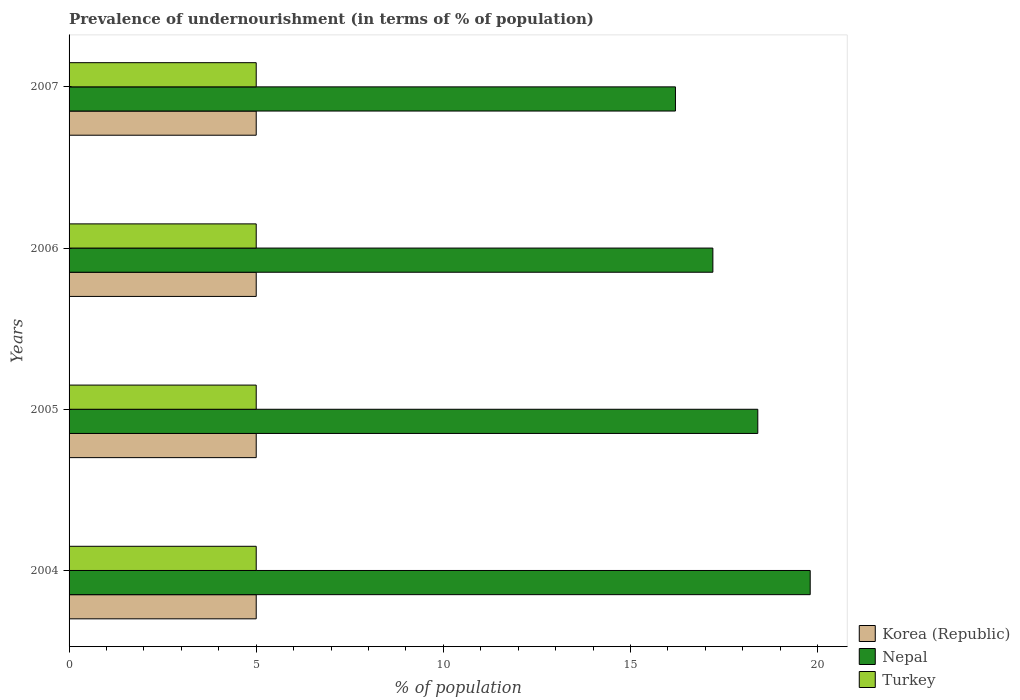How many different coloured bars are there?
Your answer should be very brief. 3. Are the number of bars per tick equal to the number of legend labels?
Provide a succinct answer. Yes. How many bars are there on the 1st tick from the top?
Ensure brevity in your answer.  3. What is the label of the 1st group of bars from the top?
Your response must be concise. 2007. What is the percentage of undernourished population in Nepal in 2004?
Give a very brief answer. 19.8. Across all years, what is the maximum percentage of undernourished population in Nepal?
Your answer should be very brief. 19.8. Across all years, what is the minimum percentage of undernourished population in Nepal?
Provide a succinct answer. 16.2. In which year was the percentage of undernourished population in Nepal maximum?
Provide a succinct answer. 2004. In which year was the percentage of undernourished population in Nepal minimum?
Make the answer very short. 2007. What is the total percentage of undernourished population in Korea (Republic) in the graph?
Provide a short and direct response. 20. What is the difference between the percentage of undernourished population in Nepal in 2004 and that in 2005?
Provide a succinct answer. 1.4. What is the average percentage of undernourished population in Turkey per year?
Give a very brief answer. 5. In how many years, is the percentage of undernourished population in Turkey greater than 3 %?
Offer a terse response. 4. Is the percentage of undernourished population in Korea (Republic) in 2004 less than that in 2006?
Your answer should be very brief. No. What is the difference between the highest and the second highest percentage of undernourished population in Korea (Republic)?
Offer a terse response. 0. What is the difference between the highest and the lowest percentage of undernourished population in Nepal?
Offer a very short reply. 3.6. What does the 2nd bar from the bottom in 2007 represents?
Your answer should be very brief. Nepal. How many bars are there?
Your answer should be very brief. 12. Are the values on the major ticks of X-axis written in scientific E-notation?
Give a very brief answer. No. Does the graph contain any zero values?
Provide a short and direct response. No. Does the graph contain grids?
Your response must be concise. No. Where does the legend appear in the graph?
Offer a very short reply. Bottom right. How many legend labels are there?
Give a very brief answer. 3. How are the legend labels stacked?
Make the answer very short. Vertical. What is the title of the graph?
Ensure brevity in your answer.  Prevalence of undernourishment (in terms of % of population). Does "Armenia" appear as one of the legend labels in the graph?
Your answer should be very brief. No. What is the label or title of the X-axis?
Give a very brief answer. % of population. What is the % of population of Korea (Republic) in 2004?
Offer a very short reply. 5. What is the % of population of Nepal in 2004?
Provide a short and direct response. 19.8. What is the % of population in Korea (Republic) in 2005?
Your answer should be very brief. 5. What is the % of population in Turkey in 2005?
Keep it short and to the point. 5. What is the % of population in Nepal in 2006?
Provide a short and direct response. 17.2. What is the % of population of Korea (Republic) in 2007?
Give a very brief answer. 5. Across all years, what is the maximum % of population in Korea (Republic)?
Provide a succinct answer. 5. Across all years, what is the maximum % of population of Nepal?
Give a very brief answer. 19.8. Across all years, what is the maximum % of population in Turkey?
Keep it short and to the point. 5. Across all years, what is the minimum % of population of Korea (Republic)?
Provide a succinct answer. 5. Across all years, what is the minimum % of population in Nepal?
Make the answer very short. 16.2. Across all years, what is the minimum % of population of Turkey?
Offer a terse response. 5. What is the total % of population in Korea (Republic) in the graph?
Your answer should be very brief. 20. What is the total % of population in Nepal in the graph?
Keep it short and to the point. 71.6. What is the total % of population in Turkey in the graph?
Offer a very short reply. 20. What is the difference between the % of population of Korea (Republic) in 2004 and that in 2005?
Offer a terse response. 0. What is the difference between the % of population in Turkey in 2004 and that in 2005?
Offer a very short reply. 0. What is the difference between the % of population of Nepal in 2004 and that in 2006?
Your answer should be compact. 2.6. What is the difference between the % of population of Korea (Republic) in 2004 and that in 2007?
Offer a terse response. 0. What is the difference between the % of population in Korea (Republic) in 2005 and that in 2006?
Make the answer very short. 0. What is the difference between the % of population of Turkey in 2005 and that in 2006?
Offer a terse response. 0. What is the difference between the % of population in Nepal in 2005 and that in 2007?
Give a very brief answer. 2.2. What is the difference between the % of population of Turkey in 2006 and that in 2007?
Keep it short and to the point. 0. What is the difference between the % of population in Korea (Republic) in 2004 and the % of population in Turkey in 2005?
Your response must be concise. 0. What is the difference between the % of population of Korea (Republic) in 2004 and the % of population of Nepal in 2006?
Your response must be concise. -12.2. What is the difference between the % of population in Korea (Republic) in 2004 and the % of population in Turkey in 2006?
Ensure brevity in your answer.  0. What is the difference between the % of population in Nepal in 2004 and the % of population in Turkey in 2006?
Make the answer very short. 14.8. What is the difference between the % of population of Korea (Republic) in 2004 and the % of population of Nepal in 2007?
Offer a terse response. -11.2. What is the difference between the % of population in Korea (Republic) in 2005 and the % of population in Nepal in 2006?
Offer a terse response. -12.2. What is the difference between the % of population of Nepal in 2005 and the % of population of Turkey in 2006?
Provide a succinct answer. 13.4. What is the difference between the % of population in Nepal in 2005 and the % of population in Turkey in 2007?
Offer a terse response. 13.4. What is the average % of population in Korea (Republic) per year?
Keep it short and to the point. 5. What is the average % of population in Nepal per year?
Give a very brief answer. 17.9. In the year 2004, what is the difference between the % of population of Korea (Republic) and % of population of Nepal?
Your response must be concise. -14.8. In the year 2004, what is the difference between the % of population in Korea (Republic) and % of population in Turkey?
Your answer should be compact. 0. In the year 2004, what is the difference between the % of population of Nepal and % of population of Turkey?
Your response must be concise. 14.8. In the year 2005, what is the difference between the % of population in Korea (Republic) and % of population in Nepal?
Your answer should be very brief. -13.4. In the year 2005, what is the difference between the % of population of Korea (Republic) and % of population of Turkey?
Give a very brief answer. 0. In the year 2006, what is the difference between the % of population in Korea (Republic) and % of population in Nepal?
Ensure brevity in your answer.  -12.2. In the year 2006, what is the difference between the % of population in Korea (Republic) and % of population in Turkey?
Keep it short and to the point. 0. In the year 2006, what is the difference between the % of population in Nepal and % of population in Turkey?
Make the answer very short. 12.2. In the year 2007, what is the difference between the % of population in Korea (Republic) and % of population in Nepal?
Provide a short and direct response. -11.2. In the year 2007, what is the difference between the % of population of Korea (Republic) and % of population of Turkey?
Provide a succinct answer. 0. In the year 2007, what is the difference between the % of population in Nepal and % of population in Turkey?
Offer a terse response. 11.2. What is the ratio of the % of population in Nepal in 2004 to that in 2005?
Make the answer very short. 1.08. What is the ratio of the % of population of Korea (Republic) in 2004 to that in 2006?
Your response must be concise. 1. What is the ratio of the % of population in Nepal in 2004 to that in 2006?
Your answer should be very brief. 1.15. What is the ratio of the % of population of Nepal in 2004 to that in 2007?
Make the answer very short. 1.22. What is the ratio of the % of population in Korea (Republic) in 2005 to that in 2006?
Make the answer very short. 1. What is the ratio of the % of population in Nepal in 2005 to that in 2006?
Provide a short and direct response. 1.07. What is the ratio of the % of population of Turkey in 2005 to that in 2006?
Offer a very short reply. 1. What is the ratio of the % of population of Korea (Republic) in 2005 to that in 2007?
Ensure brevity in your answer.  1. What is the ratio of the % of population of Nepal in 2005 to that in 2007?
Provide a succinct answer. 1.14. What is the ratio of the % of population in Turkey in 2005 to that in 2007?
Keep it short and to the point. 1. What is the ratio of the % of population of Korea (Republic) in 2006 to that in 2007?
Provide a succinct answer. 1. What is the ratio of the % of population of Nepal in 2006 to that in 2007?
Make the answer very short. 1.06. What is the ratio of the % of population of Turkey in 2006 to that in 2007?
Your answer should be very brief. 1. What is the difference between the highest and the second highest % of population of Korea (Republic)?
Give a very brief answer. 0. What is the difference between the highest and the second highest % of population in Turkey?
Give a very brief answer. 0. What is the difference between the highest and the lowest % of population of Nepal?
Offer a very short reply. 3.6. What is the difference between the highest and the lowest % of population of Turkey?
Give a very brief answer. 0. 